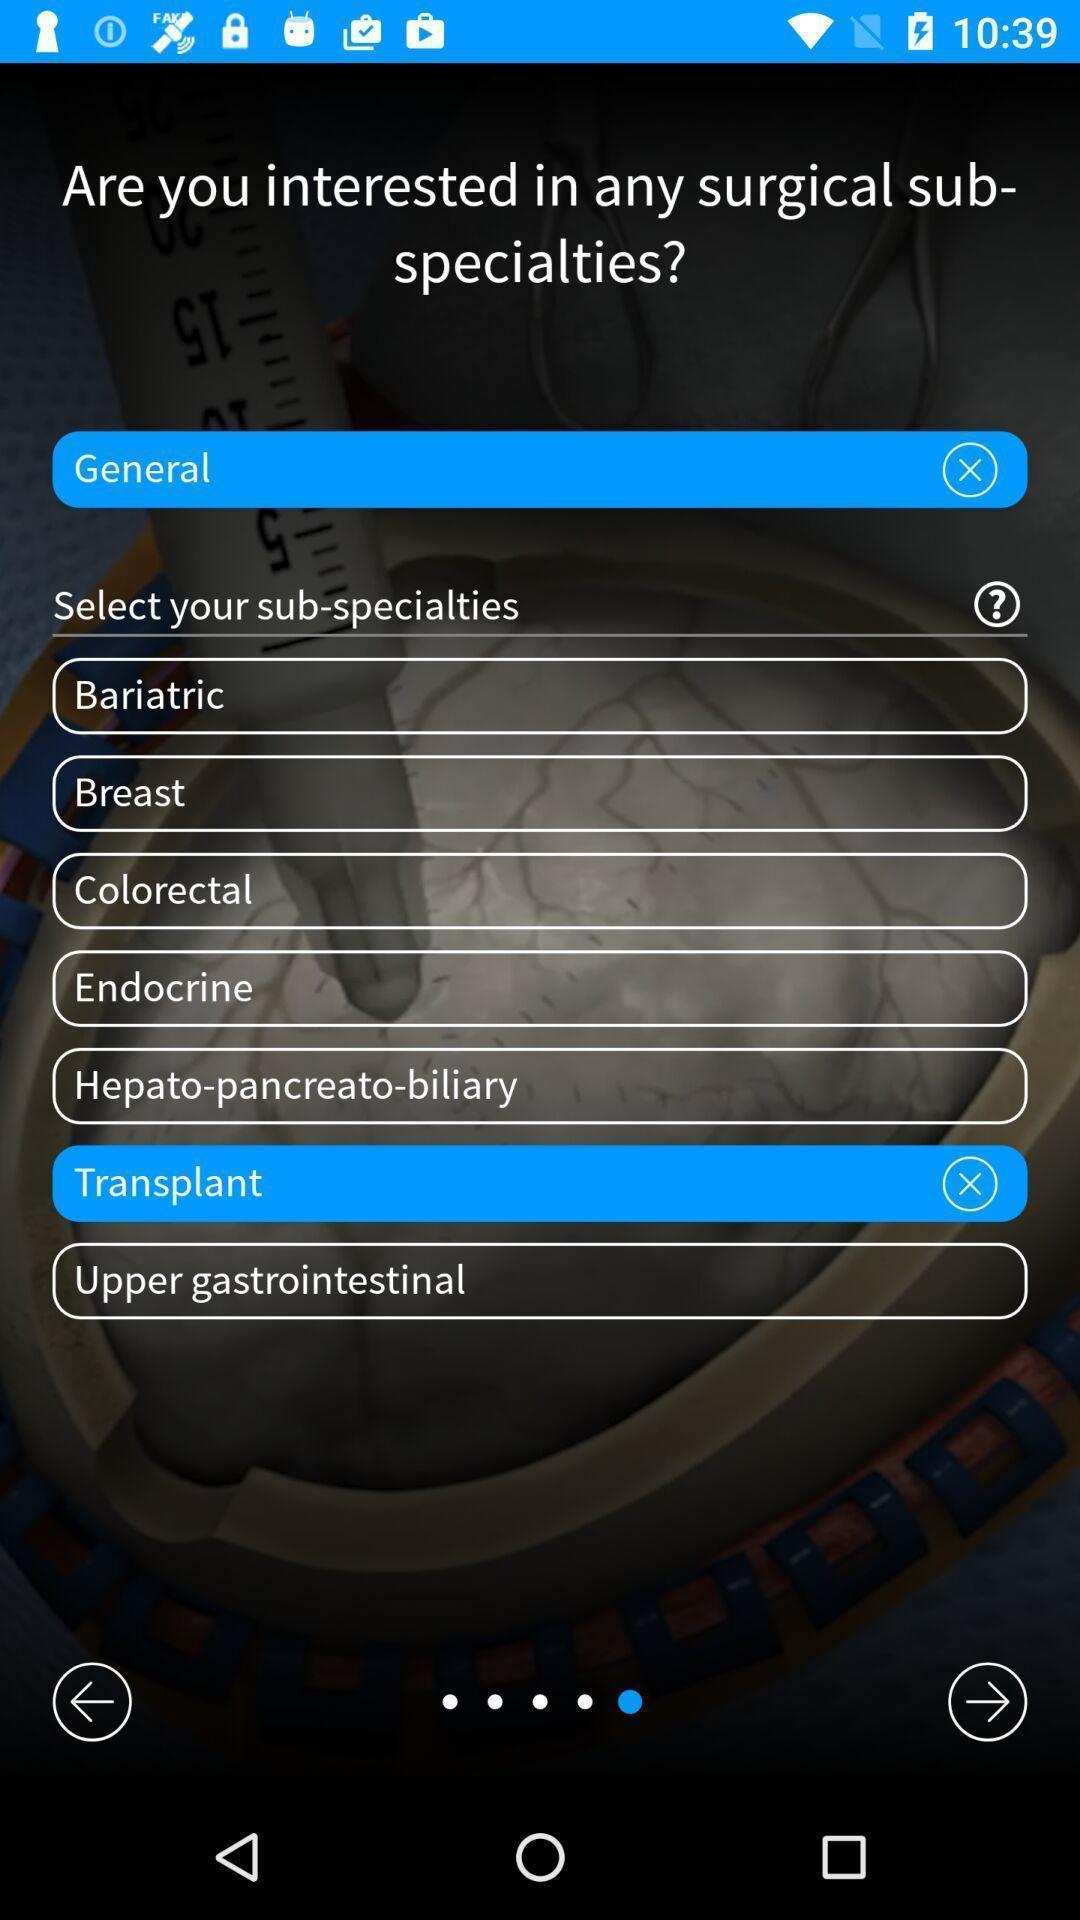Describe the key features of this screenshot. Surgical cases in surgical training app. 